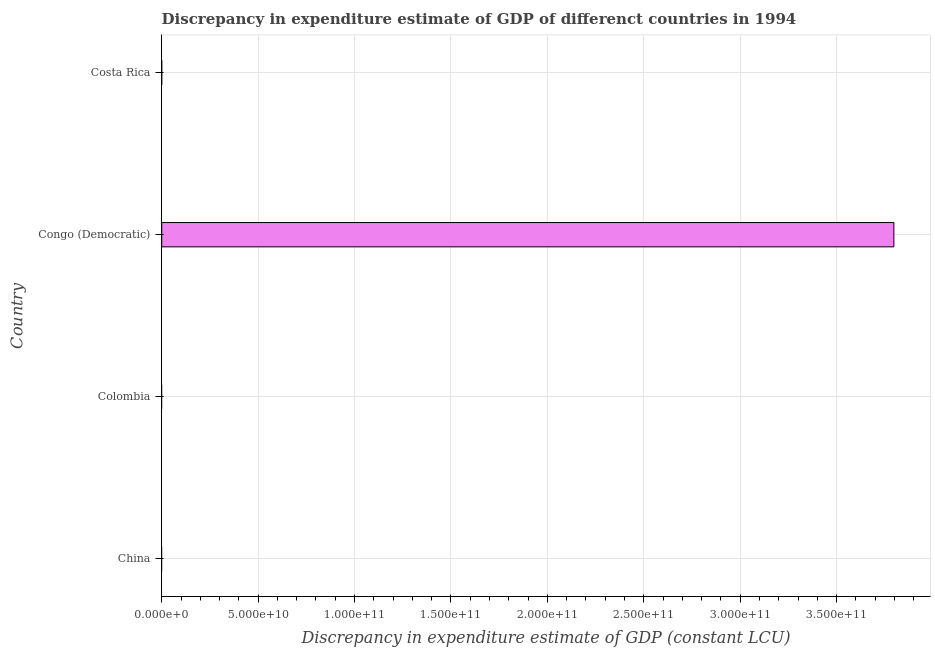Does the graph contain grids?
Offer a very short reply. Yes. What is the title of the graph?
Keep it short and to the point. Discrepancy in expenditure estimate of GDP of differenct countries in 1994. What is the label or title of the X-axis?
Give a very brief answer. Discrepancy in expenditure estimate of GDP (constant LCU). What is the label or title of the Y-axis?
Your response must be concise. Country. What is the discrepancy in expenditure estimate of gdp in Congo (Democratic)?
Your answer should be compact. 3.80e+11. Across all countries, what is the maximum discrepancy in expenditure estimate of gdp?
Your answer should be compact. 3.80e+11. In which country was the discrepancy in expenditure estimate of gdp maximum?
Offer a terse response. Congo (Democratic). What is the sum of the discrepancy in expenditure estimate of gdp?
Your answer should be very brief. 3.80e+11. What is the average discrepancy in expenditure estimate of gdp per country?
Make the answer very short. 9.49e+1. What is the ratio of the discrepancy in expenditure estimate of gdp in Congo (Democratic) to that in Costa Rica?
Your answer should be very brief. 1.27e+06. What is the difference between the highest and the lowest discrepancy in expenditure estimate of gdp?
Keep it short and to the point. 3.80e+11. Are all the bars in the graph horizontal?
Provide a short and direct response. Yes. What is the difference between two consecutive major ticks on the X-axis?
Your answer should be very brief. 5.00e+1. What is the Discrepancy in expenditure estimate of GDP (constant LCU) of China?
Make the answer very short. 0. What is the Discrepancy in expenditure estimate of GDP (constant LCU) in Congo (Democratic)?
Provide a short and direct response. 3.80e+11. What is the difference between the Discrepancy in expenditure estimate of GDP (constant LCU) in Congo (Democratic) and Costa Rica?
Ensure brevity in your answer.  3.80e+11. What is the ratio of the Discrepancy in expenditure estimate of GDP (constant LCU) in Congo (Democratic) to that in Costa Rica?
Your response must be concise. 1.27e+06. 